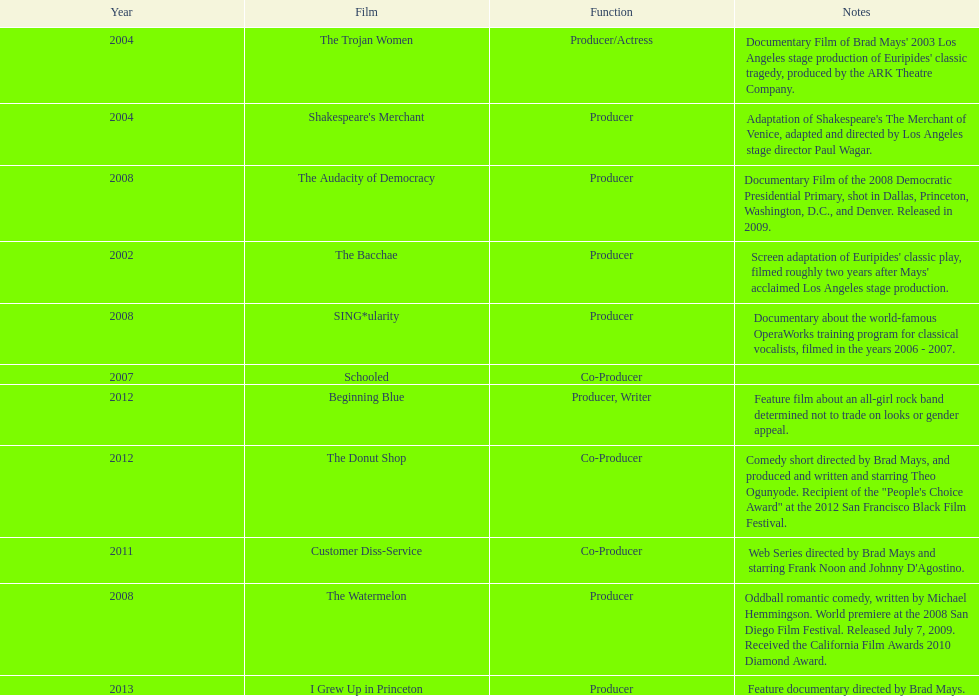What movie preceded the audacity of democracy? The Watermelon. 